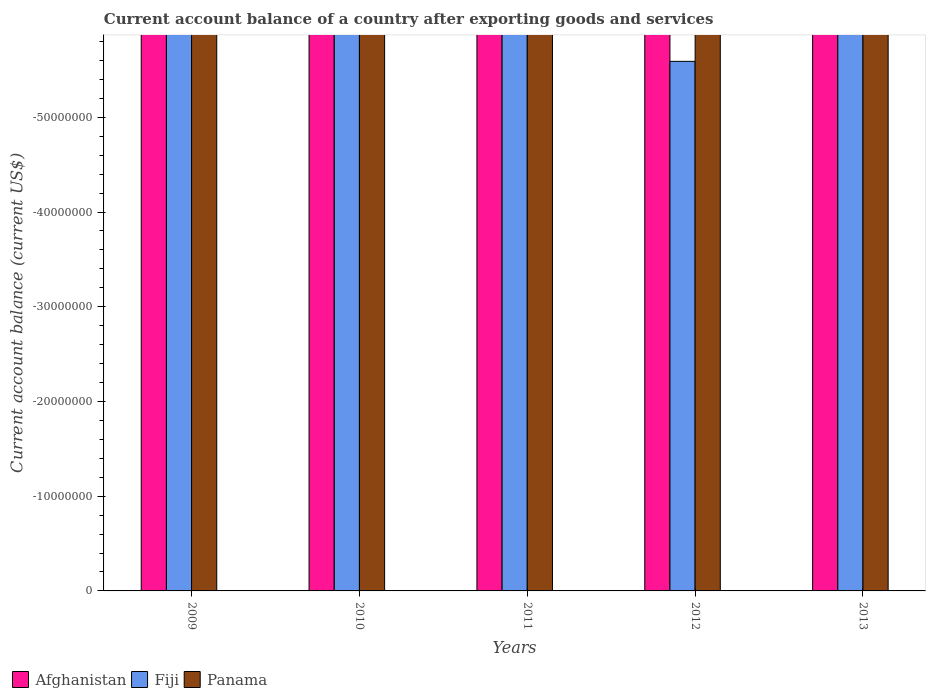Are the number of bars on each tick of the X-axis equal?
Your response must be concise. Yes. In how many cases, is the number of bars for a given year not equal to the number of legend labels?
Provide a short and direct response. 5. Across all years, what is the minimum account balance in Panama?
Your answer should be very brief. 0. What is the difference between the account balance in Afghanistan in 2011 and the account balance in Fiji in 2009?
Offer a terse response. 0. In how many years, is the account balance in Panama greater than -8000000 US$?
Ensure brevity in your answer.  0. In how many years, is the account balance in Panama greater than the average account balance in Panama taken over all years?
Your answer should be compact. 0. Are the values on the major ticks of Y-axis written in scientific E-notation?
Provide a succinct answer. No. How many legend labels are there?
Provide a short and direct response. 3. How are the legend labels stacked?
Provide a succinct answer. Horizontal. What is the title of the graph?
Your response must be concise. Current account balance of a country after exporting goods and services. Does "South Asia" appear as one of the legend labels in the graph?
Offer a terse response. No. What is the label or title of the Y-axis?
Your answer should be very brief. Current account balance (current US$). What is the Current account balance (current US$) of Afghanistan in 2009?
Keep it short and to the point. 0. What is the Current account balance (current US$) in Fiji in 2009?
Your answer should be compact. 0. What is the Current account balance (current US$) in Afghanistan in 2010?
Provide a short and direct response. 0. What is the Current account balance (current US$) in Fiji in 2011?
Make the answer very short. 0. What is the Current account balance (current US$) of Afghanistan in 2012?
Your answer should be compact. 0. What is the Current account balance (current US$) in Panama in 2012?
Offer a terse response. 0. What is the Current account balance (current US$) of Afghanistan in 2013?
Your response must be concise. 0. What is the Current account balance (current US$) of Fiji in 2013?
Keep it short and to the point. 0. What is the Current account balance (current US$) in Panama in 2013?
Your answer should be compact. 0. What is the total Current account balance (current US$) of Fiji in the graph?
Make the answer very short. 0. What is the average Current account balance (current US$) in Afghanistan per year?
Offer a very short reply. 0. 